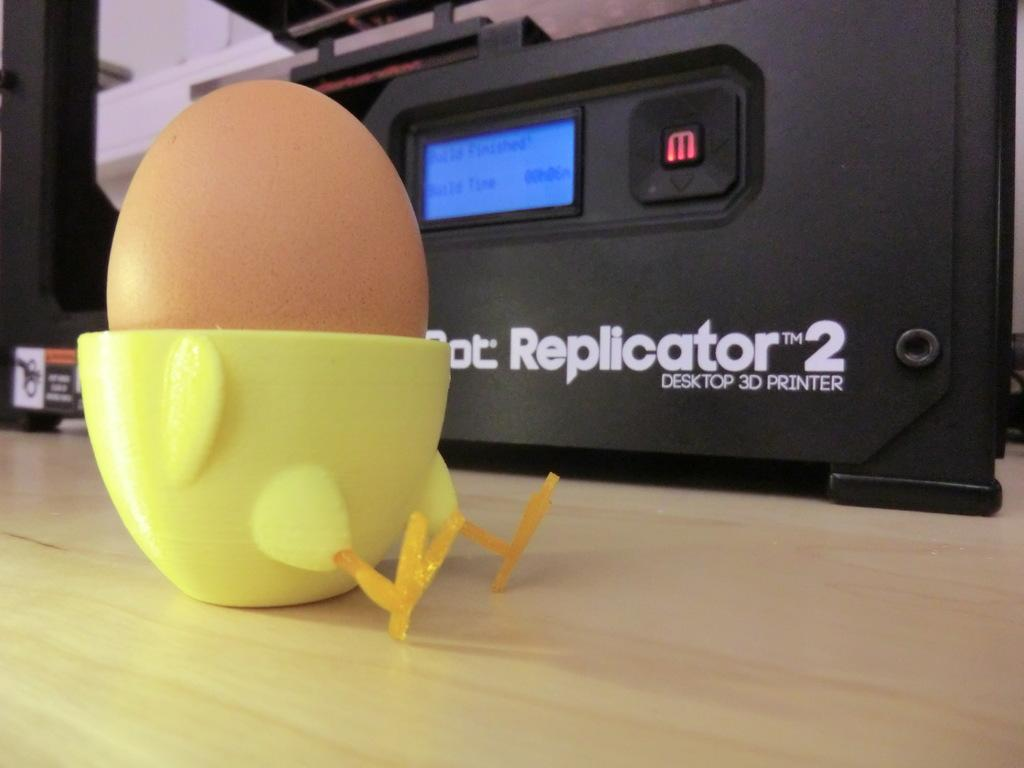What object is placed on the table in the image? There is a toy placed on the table. What can be seen in the background of the image? There is a printer in the background of the image. Where is the monkey in the image? There is no monkey present in the image. What advice might the grandmother give in the image? There is no grandmother present in the image, so it is not possible to determine what advice she might give. 